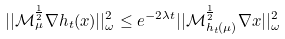Convert formula to latex. <formula><loc_0><loc_0><loc_500><loc_500>| | \mathcal { M } _ { \mu } ^ { \frac { 1 } { 2 } } \nabla h _ { t } ( x ) | | _ { \omega } ^ { 2 } \leq e ^ { - 2 \lambda t } | | \mathcal { M } _ { h _ { t } ( \mu ) } ^ { \frac { 1 } { 2 } } \nabla x | | _ { \omega } ^ { 2 }</formula> 